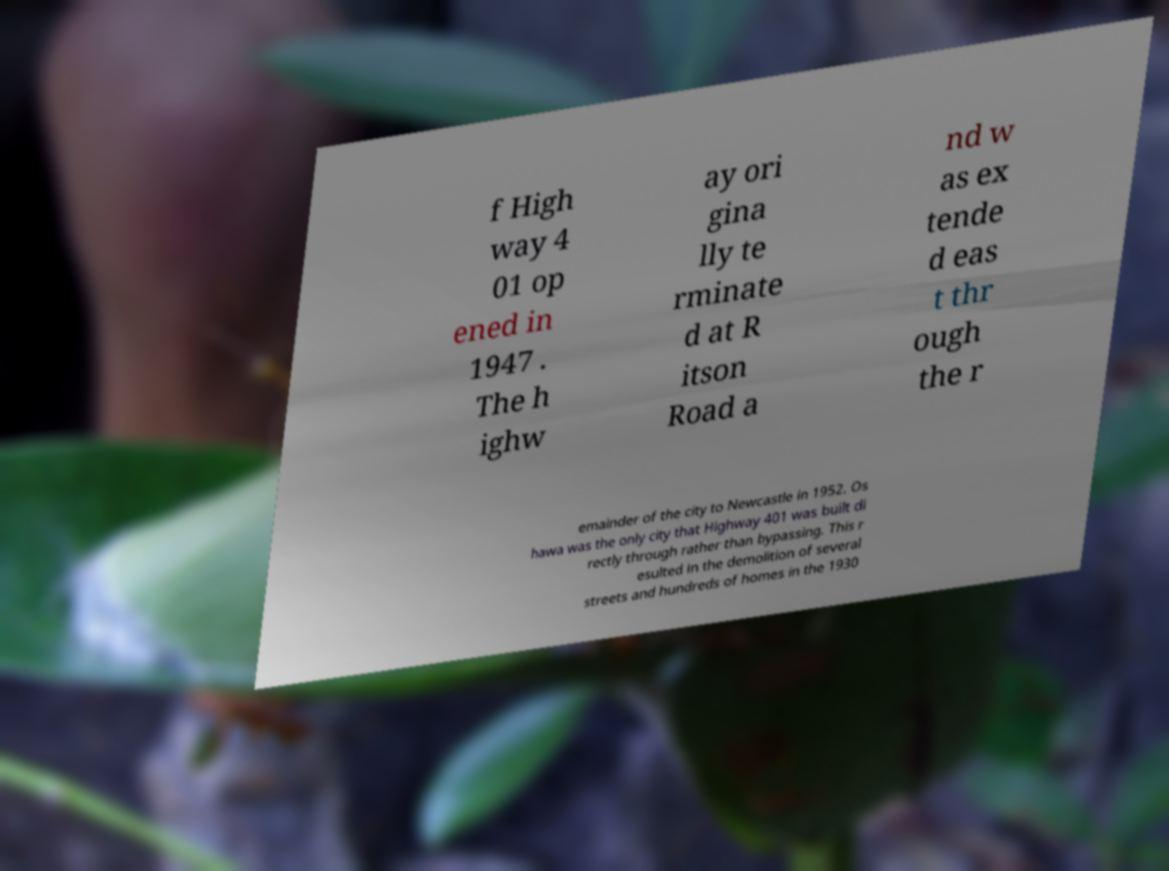I need the written content from this picture converted into text. Can you do that? f High way 4 01 op ened in 1947 . The h ighw ay ori gina lly te rminate d at R itson Road a nd w as ex tende d eas t thr ough the r emainder of the city to Newcastle in 1952. Os hawa was the only city that Highway 401 was built di rectly through rather than bypassing. This r esulted in the demolition of several streets and hundreds of homes in the 1930 